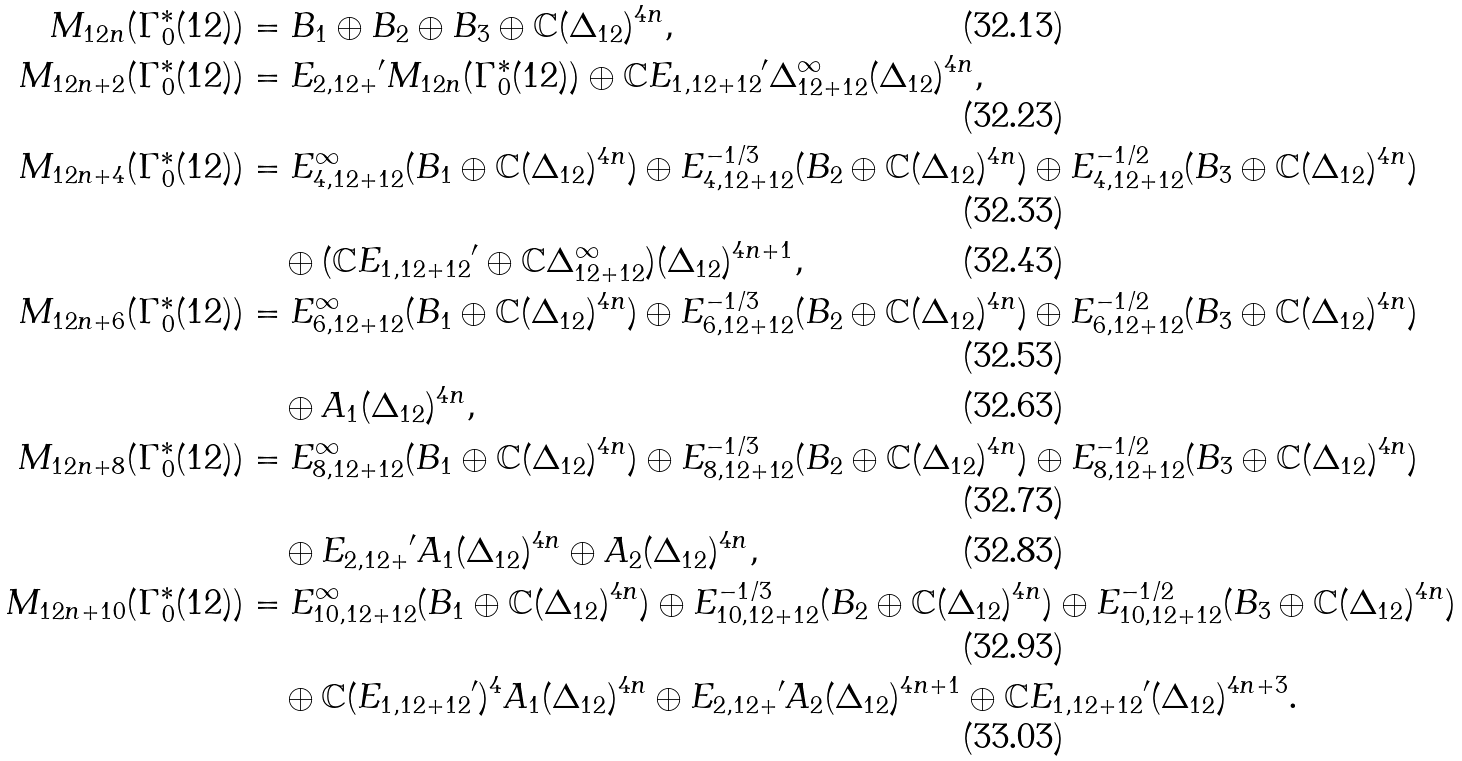Convert formula to latex. <formula><loc_0><loc_0><loc_500><loc_500>M _ { 1 2 n } ( \Gamma _ { 0 } ^ { * } ( 1 2 ) ) & = B _ { 1 } \oplus B _ { 2 } \oplus B _ { 3 } \oplus \mathbb { C } ( \Delta _ { 1 2 } ) ^ { 4 n } , \\ M _ { 1 2 n + 2 } ( \Gamma _ { 0 } ^ { * } ( 1 2 ) ) & = { E _ { 2 , 1 2 + } } ^ { \prime } M _ { 1 2 n } ( \Gamma _ { 0 } ^ { * } ( 1 2 ) ) \oplus \mathbb { C } { E _ { 1 , 1 2 + 1 2 } } ^ { \prime } \Delta _ { 1 2 + 1 2 } ^ { \infty } ( \Delta _ { 1 2 } ) ^ { 4 n } , \\ M _ { 1 2 n + 4 } ( \Gamma _ { 0 } ^ { * } ( 1 2 ) ) & = E _ { 4 , 1 2 + 1 2 } ^ { \infty } ( B _ { 1 } \oplus \mathbb { C } ( \Delta _ { 1 2 } ) ^ { 4 n } ) \oplus E _ { 4 , 1 2 + 1 2 } ^ { - 1 / 3 } ( B _ { 2 } \oplus \mathbb { C } ( \Delta _ { 1 2 } ) ^ { 4 n } ) \oplus E _ { 4 , 1 2 + 1 2 } ^ { - 1 / 2 } ( B _ { 3 } \oplus \mathbb { C } ( \Delta _ { 1 2 } ) ^ { 4 n } ) \\ & \quad \oplus ( \mathbb { C } { E _ { 1 , 1 2 + 1 2 } } ^ { \prime } \oplus \mathbb { C } \Delta _ { 1 2 + 1 2 } ^ { \infty } ) ( \Delta _ { 1 2 } ) ^ { 4 n + 1 } , \\ M _ { 1 2 n + 6 } ( \Gamma _ { 0 } ^ { * } ( 1 2 ) ) & = E _ { 6 , 1 2 + 1 2 } ^ { \infty } ( B _ { 1 } \oplus \mathbb { C } ( \Delta _ { 1 2 } ) ^ { 4 n } ) \oplus E _ { 6 , 1 2 + 1 2 } ^ { - 1 / 3 } ( B _ { 2 } \oplus \mathbb { C } ( \Delta _ { 1 2 } ) ^ { 4 n } ) \oplus E _ { 6 , 1 2 + 1 2 } ^ { - 1 / 2 } ( B _ { 3 } \oplus \mathbb { C } ( \Delta _ { 1 2 } ) ^ { 4 n } ) \\ & \quad \oplus A _ { 1 } ( \Delta _ { 1 2 } ) ^ { 4 n } , \\ M _ { 1 2 n + 8 } ( \Gamma _ { 0 } ^ { * } ( 1 2 ) ) & = E _ { 8 , 1 2 + 1 2 } ^ { \infty } ( B _ { 1 } \oplus \mathbb { C } ( \Delta _ { 1 2 } ) ^ { 4 n } ) \oplus E _ { 8 , 1 2 + 1 2 } ^ { - 1 / 3 } ( B _ { 2 } \oplus \mathbb { C } ( \Delta _ { 1 2 } ) ^ { 4 n } ) \oplus E _ { 8 , 1 2 + 1 2 } ^ { - 1 / 2 } ( B _ { 3 } \oplus \mathbb { C } ( \Delta _ { 1 2 } ) ^ { 4 n } ) \\ & \quad \oplus { E _ { 2 , 1 2 + } } ^ { \prime } A _ { 1 } ( \Delta _ { 1 2 } ) ^ { 4 n } \oplus A _ { 2 } ( \Delta _ { 1 2 } ) ^ { 4 n } , \\ M _ { 1 2 n + 1 0 } ( \Gamma _ { 0 } ^ { * } ( 1 2 ) ) & = E _ { 1 0 , 1 2 + 1 2 } ^ { \infty } ( B _ { 1 } \oplus \mathbb { C } ( \Delta _ { 1 2 } ) ^ { 4 n } ) \oplus E _ { 1 0 , 1 2 + 1 2 } ^ { - 1 / 3 } ( B _ { 2 } \oplus \mathbb { C } ( \Delta _ { 1 2 } ) ^ { 4 n } ) \oplus E _ { 1 0 , 1 2 + 1 2 } ^ { - 1 / 2 } ( B _ { 3 } \oplus \mathbb { C } ( \Delta _ { 1 2 } ) ^ { 4 n } ) \\ & \quad \oplus \mathbb { C } ( { E _ { 1 , 1 2 + 1 2 } } ^ { \prime } ) ^ { 4 } A _ { 1 } ( \Delta _ { 1 2 } ) ^ { 4 n } \oplus { E _ { 2 , 1 2 + } } ^ { \prime } A _ { 2 } ( \Delta _ { 1 2 } ) ^ { 4 n + 1 } \oplus \mathbb { C } { E _ { 1 , 1 2 + 1 2 } } ^ { \prime } ( \Delta _ { 1 2 } ) ^ { 4 n + 3 } .</formula> 